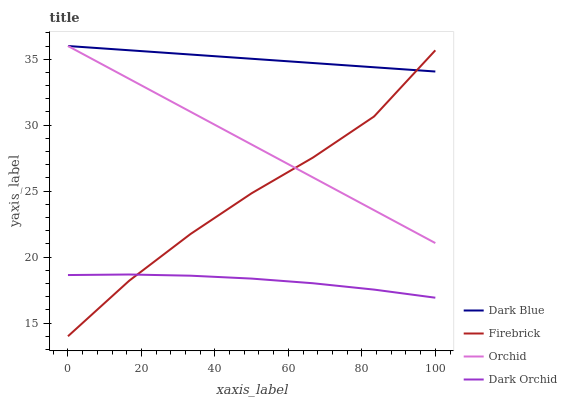Does Dark Orchid have the minimum area under the curve?
Answer yes or no. Yes. Does Dark Blue have the maximum area under the curve?
Answer yes or no. Yes. Does Firebrick have the minimum area under the curve?
Answer yes or no. No. Does Firebrick have the maximum area under the curve?
Answer yes or no. No. Is Orchid the smoothest?
Answer yes or no. Yes. Is Firebrick the roughest?
Answer yes or no. Yes. Is Dark Orchid the smoothest?
Answer yes or no. No. Is Dark Orchid the roughest?
Answer yes or no. No. Does Firebrick have the lowest value?
Answer yes or no. Yes. Does Dark Orchid have the lowest value?
Answer yes or no. No. Does Orchid have the highest value?
Answer yes or no. Yes. Does Firebrick have the highest value?
Answer yes or no. No. Is Dark Orchid less than Dark Blue?
Answer yes or no. Yes. Is Dark Blue greater than Dark Orchid?
Answer yes or no. Yes. Does Orchid intersect Firebrick?
Answer yes or no. Yes. Is Orchid less than Firebrick?
Answer yes or no. No. Is Orchid greater than Firebrick?
Answer yes or no. No. Does Dark Orchid intersect Dark Blue?
Answer yes or no. No. 